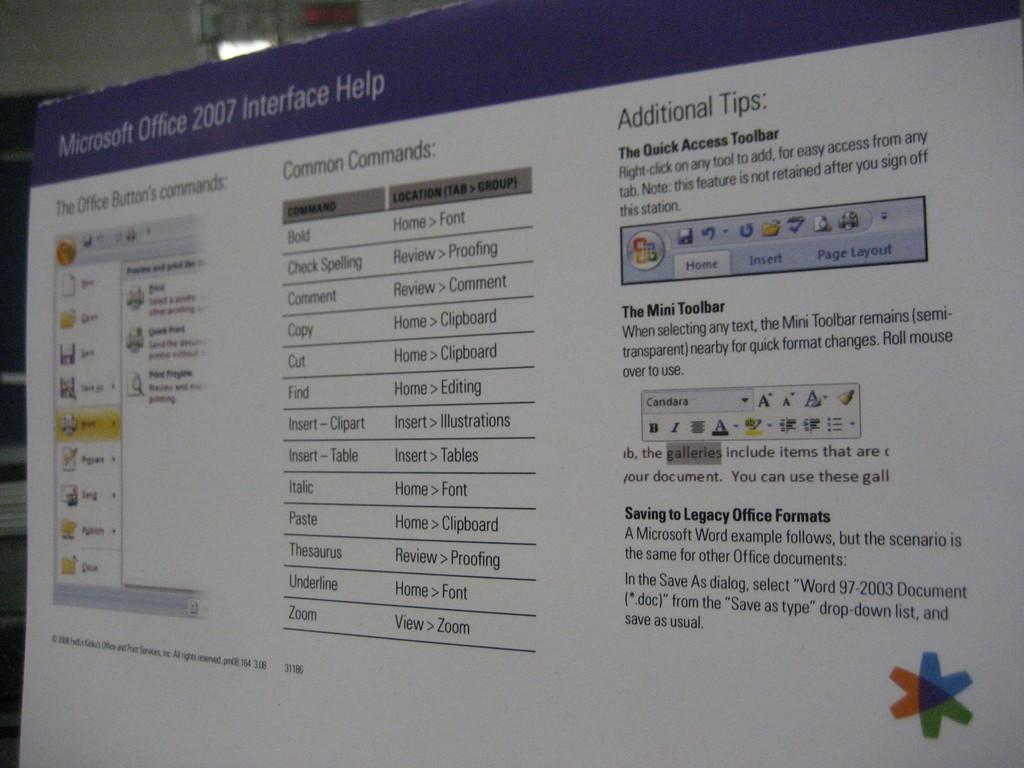<image>
Render a clear and concise summary of the photo. The screen is from Microsoft Office 2007 and is a help screen 